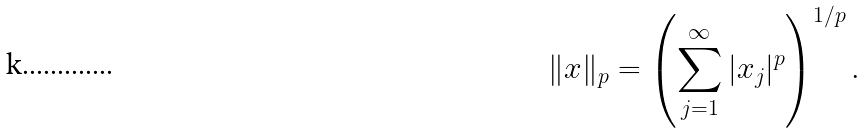<formula> <loc_0><loc_0><loc_500><loc_500>\| x \| _ { p } = \left ( \sum _ { j = 1 } ^ { \infty } | x _ { j } | ^ { p } \right ) ^ { 1 / p } .</formula> 